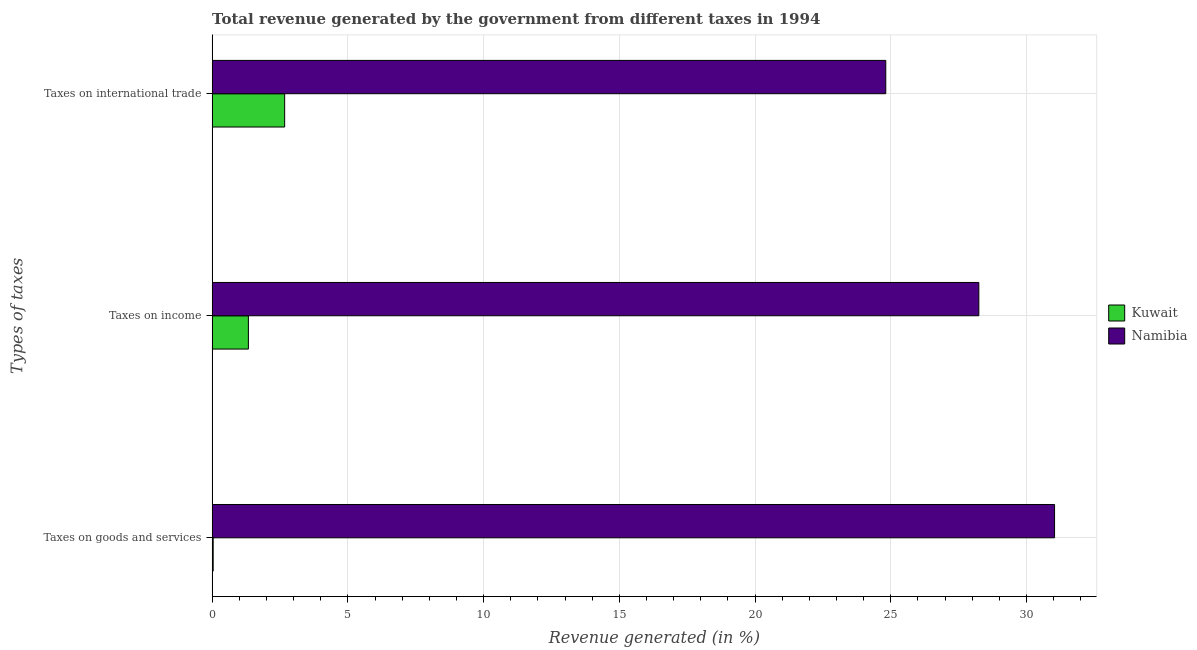Are the number of bars per tick equal to the number of legend labels?
Give a very brief answer. Yes. Are the number of bars on each tick of the Y-axis equal?
Offer a terse response. Yes. How many bars are there on the 3rd tick from the bottom?
Give a very brief answer. 2. What is the label of the 1st group of bars from the top?
Your answer should be very brief. Taxes on international trade. What is the percentage of revenue generated by tax on international trade in Kuwait?
Provide a succinct answer. 2.67. Across all countries, what is the maximum percentage of revenue generated by tax on international trade?
Offer a very short reply. 24.81. Across all countries, what is the minimum percentage of revenue generated by tax on international trade?
Provide a short and direct response. 2.67. In which country was the percentage of revenue generated by taxes on income maximum?
Provide a succinct answer. Namibia. In which country was the percentage of revenue generated by taxes on income minimum?
Keep it short and to the point. Kuwait. What is the total percentage of revenue generated by tax on international trade in the graph?
Provide a short and direct response. 27.49. What is the difference between the percentage of revenue generated by tax on international trade in Namibia and that in Kuwait?
Provide a short and direct response. 22.14. What is the difference between the percentage of revenue generated by taxes on income in Namibia and the percentage of revenue generated by taxes on goods and services in Kuwait?
Ensure brevity in your answer.  28.2. What is the average percentage of revenue generated by taxes on income per country?
Provide a succinct answer. 14.79. What is the difference between the percentage of revenue generated by taxes on goods and services and percentage of revenue generated by tax on international trade in Kuwait?
Provide a succinct answer. -2.63. In how many countries, is the percentage of revenue generated by taxes on income greater than 6 %?
Provide a succinct answer. 1. What is the ratio of the percentage of revenue generated by taxes on goods and services in Kuwait to that in Namibia?
Your answer should be compact. 0. Is the percentage of revenue generated by tax on international trade in Namibia less than that in Kuwait?
Give a very brief answer. No. Is the difference between the percentage of revenue generated by taxes on goods and services in Kuwait and Namibia greater than the difference between the percentage of revenue generated by tax on international trade in Kuwait and Namibia?
Ensure brevity in your answer.  No. What is the difference between the highest and the second highest percentage of revenue generated by taxes on goods and services?
Offer a terse response. 30.99. What is the difference between the highest and the lowest percentage of revenue generated by taxes on goods and services?
Ensure brevity in your answer.  30.99. In how many countries, is the percentage of revenue generated by taxes on goods and services greater than the average percentage of revenue generated by taxes on goods and services taken over all countries?
Keep it short and to the point. 1. Is the sum of the percentage of revenue generated by tax on international trade in Namibia and Kuwait greater than the maximum percentage of revenue generated by taxes on goods and services across all countries?
Offer a very short reply. No. What does the 1st bar from the top in Taxes on income represents?
Ensure brevity in your answer.  Namibia. What does the 2nd bar from the bottom in Taxes on goods and services represents?
Your response must be concise. Namibia. Is it the case that in every country, the sum of the percentage of revenue generated by taxes on goods and services and percentage of revenue generated by taxes on income is greater than the percentage of revenue generated by tax on international trade?
Offer a very short reply. No. How many bars are there?
Make the answer very short. 6. What is the difference between two consecutive major ticks on the X-axis?
Make the answer very short. 5. Does the graph contain any zero values?
Make the answer very short. No. Where does the legend appear in the graph?
Offer a very short reply. Center right. What is the title of the graph?
Provide a short and direct response. Total revenue generated by the government from different taxes in 1994. Does "Morocco" appear as one of the legend labels in the graph?
Your response must be concise. No. What is the label or title of the X-axis?
Your response must be concise. Revenue generated (in %). What is the label or title of the Y-axis?
Give a very brief answer. Types of taxes. What is the Revenue generated (in %) in Kuwait in Taxes on goods and services?
Offer a very short reply. 0.04. What is the Revenue generated (in %) of Namibia in Taxes on goods and services?
Keep it short and to the point. 31.03. What is the Revenue generated (in %) of Kuwait in Taxes on income?
Provide a succinct answer. 1.34. What is the Revenue generated (in %) in Namibia in Taxes on income?
Offer a terse response. 28.24. What is the Revenue generated (in %) in Kuwait in Taxes on international trade?
Make the answer very short. 2.67. What is the Revenue generated (in %) in Namibia in Taxes on international trade?
Give a very brief answer. 24.81. Across all Types of taxes, what is the maximum Revenue generated (in %) of Kuwait?
Provide a short and direct response. 2.67. Across all Types of taxes, what is the maximum Revenue generated (in %) of Namibia?
Provide a short and direct response. 31.03. Across all Types of taxes, what is the minimum Revenue generated (in %) of Kuwait?
Provide a short and direct response. 0.04. Across all Types of taxes, what is the minimum Revenue generated (in %) in Namibia?
Your answer should be compact. 24.81. What is the total Revenue generated (in %) in Kuwait in the graph?
Your response must be concise. 4.05. What is the total Revenue generated (in %) of Namibia in the graph?
Provide a short and direct response. 84.09. What is the difference between the Revenue generated (in %) in Kuwait in Taxes on goods and services and that in Taxes on income?
Give a very brief answer. -1.3. What is the difference between the Revenue generated (in %) of Namibia in Taxes on goods and services and that in Taxes on income?
Give a very brief answer. 2.79. What is the difference between the Revenue generated (in %) of Kuwait in Taxes on goods and services and that in Taxes on international trade?
Your response must be concise. -2.63. What is the difference between the Revenue generated (in %) of Namibia in Taxes on goods and services and that in Taxes on international trade?
Give a very brief answer. 6.22. What is the difference between the Revenue generated (in %) in Kuwait in Taxes on income and that in Taxes on international trade?
Make the answer very short. -1.34. What is the difference between the Revenue generated (in %) in Namibia in Taxes on income and that in Taxes on international trade?
Provide a short and direct response. 3.43. What is the difference between the Revenue generated (in %) of Kuwait in Taxes on goods and services and the Revenue generated (in %) of Namibia in Taxes on income?
Provide a succinct answer. -28.2. What is the difference between the Revenue generated (in %) of Kuwait in Taxes on goods and services and the Revenue generated (in %) of Namibia in Taxes on international trade?
Provide a succinct answer. -24.77. What is the difference between the Revenue generated (in %) of Kuwait in Taxes on income and the Revenue generated (in %) of Namibia in Taxes on international trade?
Your answer should be compact. -23.48. What is the average Revenue generated (in %) of Kuwait per Types of taxes?
Your response must be concise. 1.35. What is the average Revenue generated (in %) of Namibia per Types of taxes?
Provide a short and direct response. 28.03. What is the difference between the Revenue generated (in %) in Kuwait and Revenue generated (in %) in Namibia in Taxes on goods and services?
Make the answer very short. -30.99. What is the difference between the Revenue generated (in %) of Kuwait and Revenue generated (in %) of Namibia in Taxes on income?
Provide a short and direct response. -26.91. What is the difference between the Revenue generated (in %) in Kuwait and Revenue generated (in %) in Namibia in Taxes on international trade?
Offer a very short reply. -22.14. What is the ratio of the Revenue generated (in %) in Kuwait in Taxes on goods and services to that in Taxes on income?
Provide a succinct answer. 0.03. What is the ratio of the Revenue generated (in %) in Namibia in Taxes on goods and services to that in Taxes on income?
Your answer should be very brief. 1.1. What is the ratio of the Revenue generated (in %) of Kuwait in Taxes on goods and services to that in Taxes on international trade?
Give a very brief answer. 0.01. What is the ratio of the Revenue generated (in %) in Namibia in Taxes on goods and services to that in Taxes on international trade?
Give a very brief answer. 1.25. What is the ratio of the Revenue generated (in %) in Namibia in Taxes on income to that in Taxes on international trade?
Offer a very short reply. 1.14. What is the difference between the highest and the second highest Revenue generated (in %) of Kuwait?
Keep it short and to the point. 1.34. What is the difference between the highest and the second highest Revenue generated (in %) of Namibia?
Offer a terse response. 2.79. What is the difference between the highest and the lowest Revenue generated (in %) of Kuwait?
Offer a terse response. 2.63. What is the difference between the highest and the lowest Revenue generated (in %) in Namibia?
Provide a succinct answer. 6.22. 